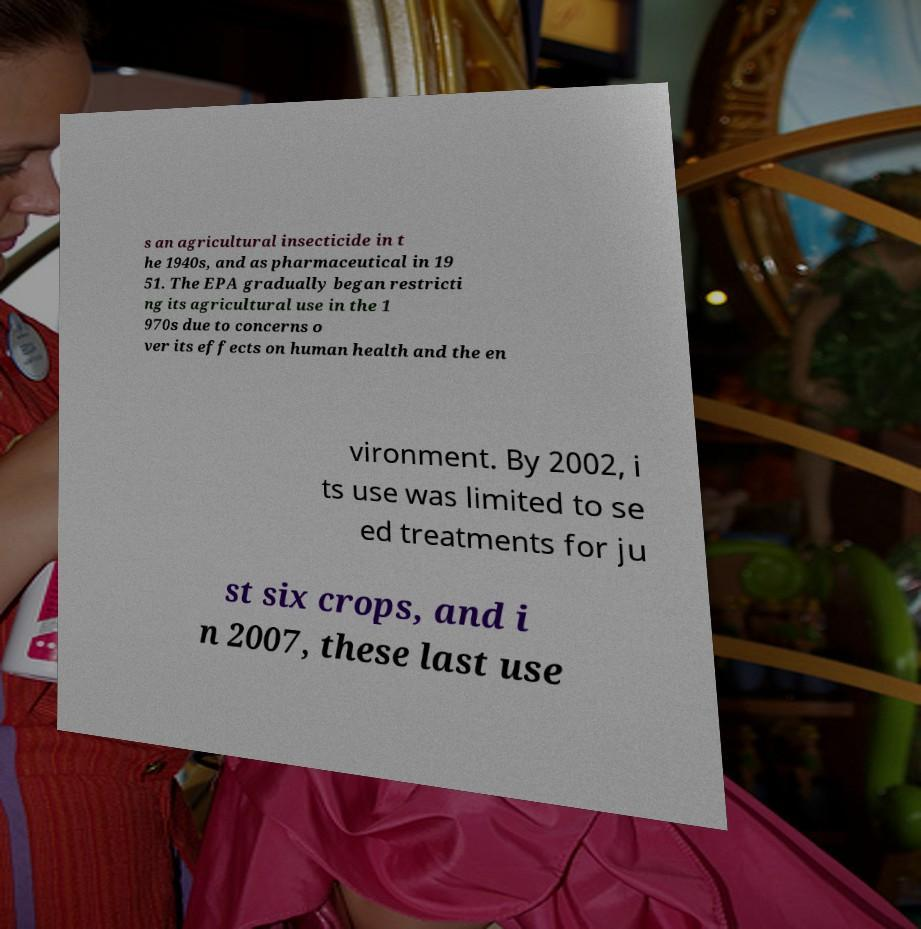Could you assist in decoding the text presented in this image and type it out clearly? s an agricultural insecticide in t he 1940s, and as pharmaceutical in 19 51. The EPA gradually began restricti ng its agricultural use in the 1 970s due to concerns o ver its effects on human health and the en vironment. By 2002, i ts use was limited to se ed treatments for ju st six crops, and i n 2007, these last use 